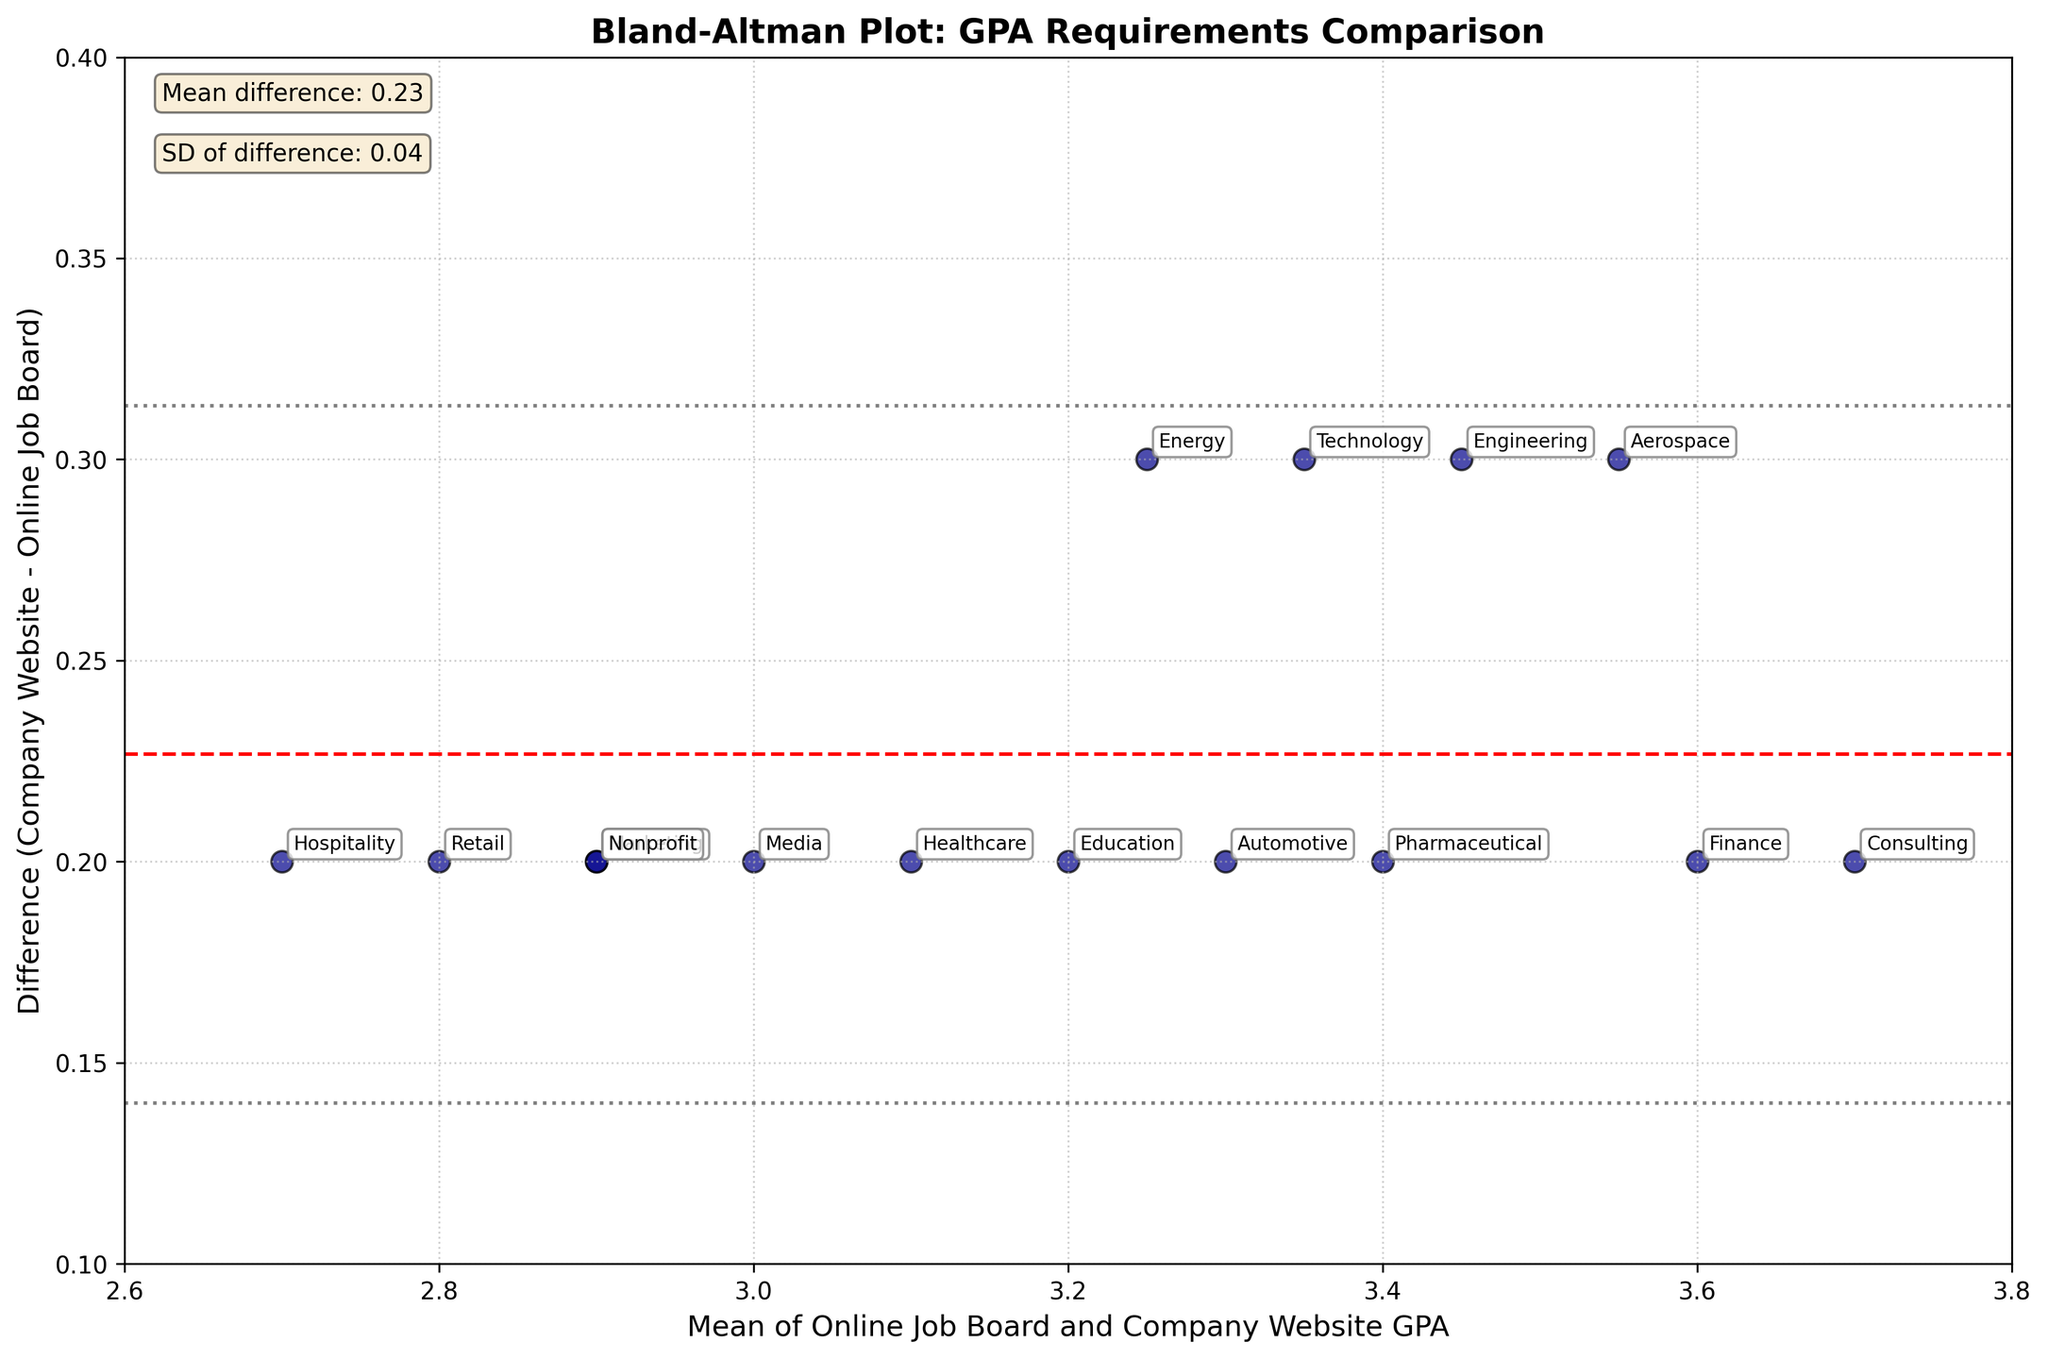What is the title of the Bland-Altman plot? The title is located at the top of the Bland-Altman plot and it indicates the main topic or content of the plot. In this case, it explains that the plot is about comparing the GPA requirements for internships.
Answer: Bland-Altman Plot: GPA Requirements Comparison What do the x and y axes represent? The labels on the axes provide this information. In this case, the x-axis label indicates it represents the mean of Online Job Board and Company Website GPA, while the y-axis label indicates it represents the difference between the Company Website and Online Job Board GPA.
Answer: The x-axis is the mean of Online Job Board and Company Website GPA; the y-axis is the difference (Company Website - Online Job Board) How many industries are compared in the Bland-Altman plot? Each data point on the plot corresponds to one industry. By counting these points, one can determine the number of industries compared.
Answer: 15 What is the mean difference in GPA between Company Website and Online Job Board across industries? The mean difference line is represented by a horizontal red dashed line. The exact value is often annotated somewhere on the plot.
Answer: 0.24 Which industry shows the highest positive difference in GPA between Company Website and Online Job Board listings? By examining the vertical position of the points on the plot and their labels, the industry with the highest positive difference is the one furthest above the x-axis.
Answer: Engineering Which industry shows the lowest positive difference in GPA between Company Website and Online Job Board listings? By examining the vertical position of the points on the plot and their labels, the industry with the lowest positive difference is the one closest to the x-axis but still above it.
Answer: Hospitality What is the standard deviation of the differences? The standard deviation of the differences is often annotated on the plot. It can be represented by the distances between the mean line and the dotted lines.
Answer: 0.10 Is there any industry where the GPA requirement on Online Job Boards is higher than on Company Websites? By examining the positions of the points below the x-axis, the industries corresponding to those points indicate where the GPA on Online Job Boards is higher.
Answer: No What do the gray dotted lines represent? These lines are ±1.96 standard deviations from the mean difference, which typically indicates the limits of agreement.
Answer: Limits of Agreement Are there any industries outside the limits of agreement? Points outside the gray dotted lines represent industries with differences beyond ±1.96 standard deviations from the mean difference.
Answer: No 